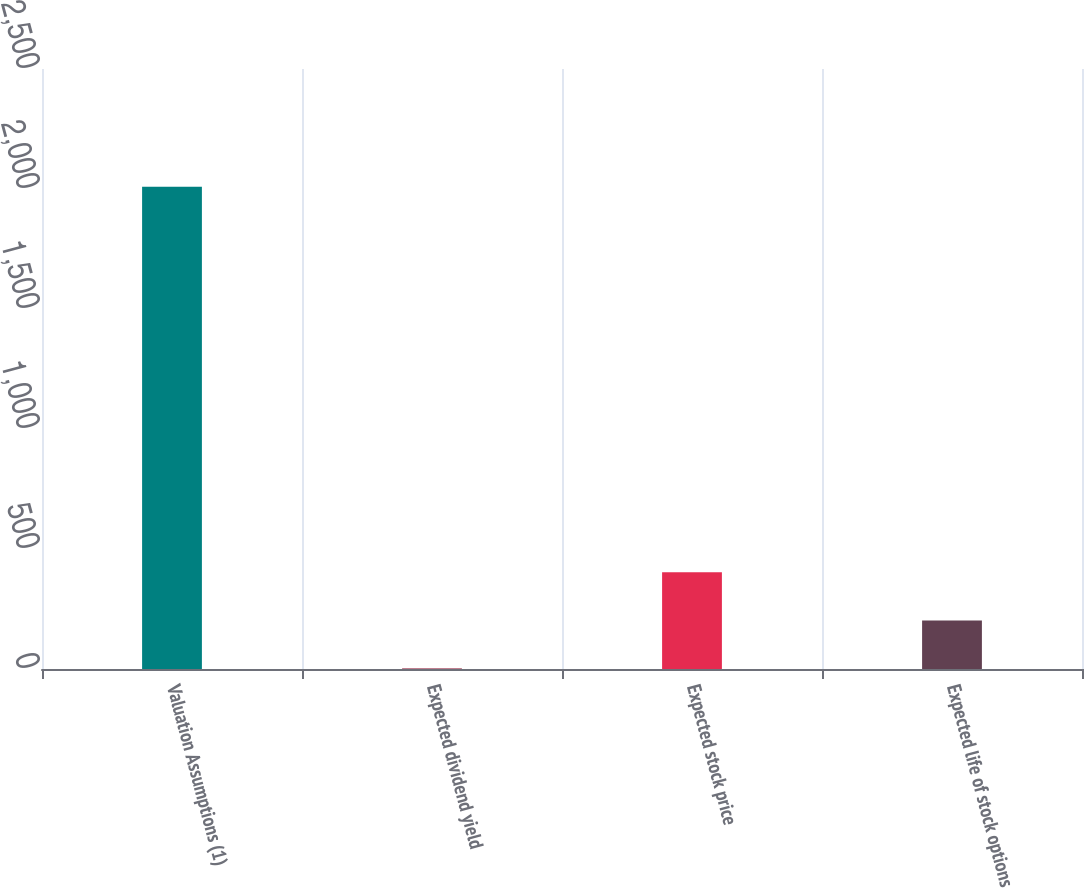Convert chart to OTSL. <chart><loc_0><loc_0><loc_500><loc_500><bar_chart><fcel>Valuation Assumptions (1)<fcel>Expected dividend yield<fcel>Expected stock price<fcel>Expected life of stock options<nl><fcel>2009<fcel>1.6<fcel>403.08<fcel>202.34<nl></chart> 